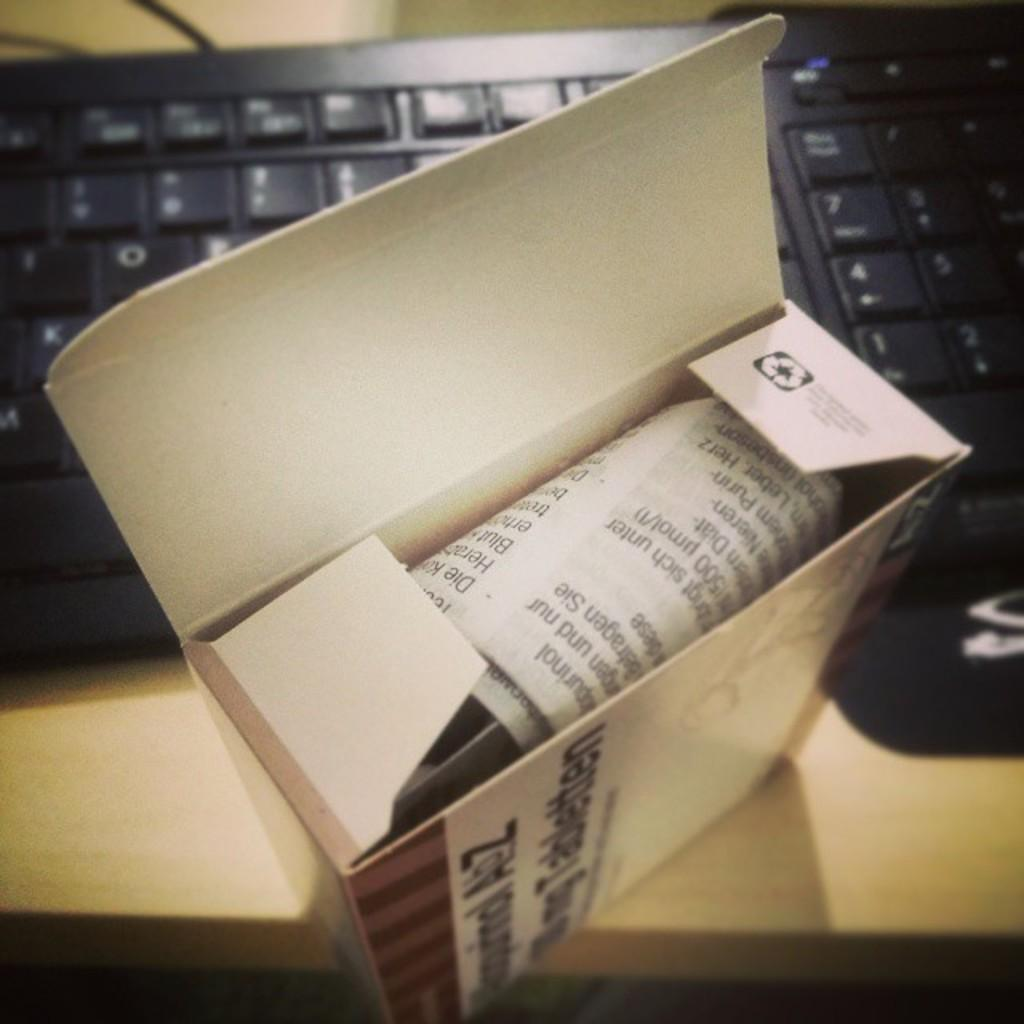Provide a one-sentence caption for the provided image. Box sitting in front of a keyboard that has instructions inside with the letters Die on it. 